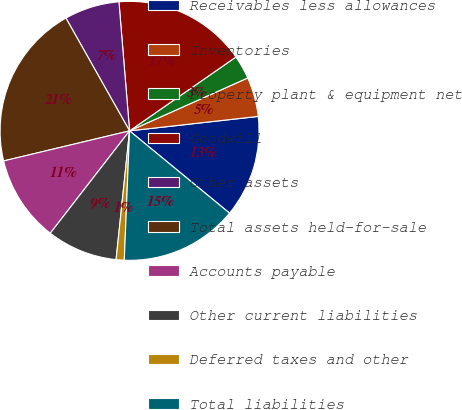Convert chart to OTSL. <chart><loc_0><loc_0><loc_500><loc_500><pie_chart><fcel>Receivables less allowances<fcel>Inventories<fcel>Property plant & equipment net<fcel>Goodwill<fcel>Other assets<fcel>Total assets held-for-sale<fcel>Accounts payable<fcel>Other current liabilities<fcel>Deferred taxes and other<fcel>Total liabilities<nl><fcel>12.74%<fcel>4.92%<fcel>2.96%<fcel>16.65%<fcel>6.87%<fcel>20.56%<fcel>10.78%<fcel>8.83%<fcel>1.01%<fcel>14.69%<nl></chart> 